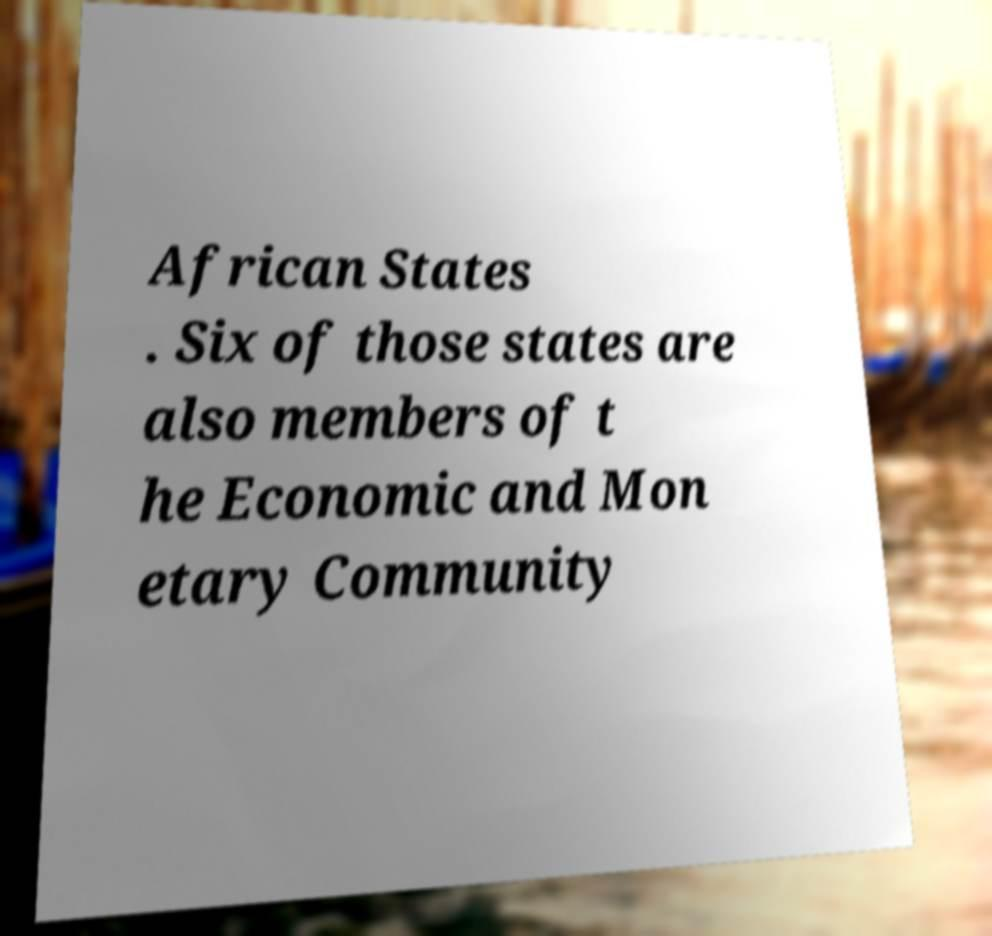Please read and relay the text visible in this image. What does it say? African States . Six of those states are also members of t he Economic and Mon etary Community 